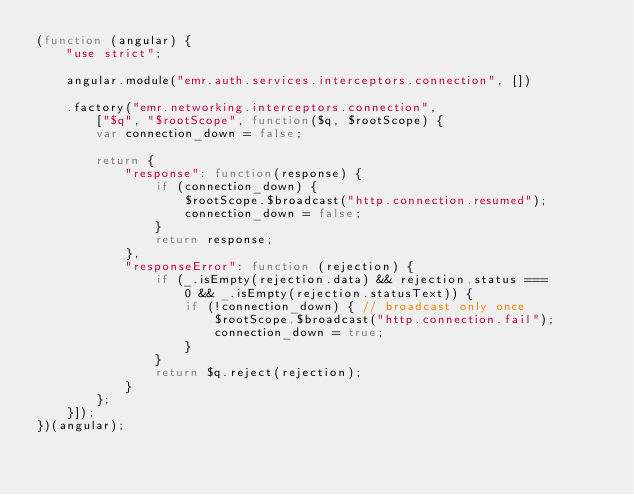Convert code to text. <code><loc_0><loc_0><loc_500><loc_500><_JavaScript_>(function (angular) {
    "use strict";

    angular.module("emr.auth.services.interceptors.connection", [])

    .factory("emr.networking.interceptors.connection",
        ["$q", "$rootScope", function($q, $rootScope) {
        var connection_down = false;

        return {
            "response": function(response) {
                if (connection_down) {
                    $rootScope.$broadcast("http.connection.resumed");
                    connection_down = false;
                }
                return response;
            },
            "responseError": function (rejection) {
                if (_.isEmpty(rejection.data) && rejection.status ===
                    0 && _.isEmpty(rejection.statusText)) {
                    if (!connection_down) { // broadcast only once
                        $rootScope.$broadcast("http.connection.fail");
                        connection_down = true;
                    }
                }
                return $q.reject(rejection);
            }
        };
    }]);
})(angular);
</code> 